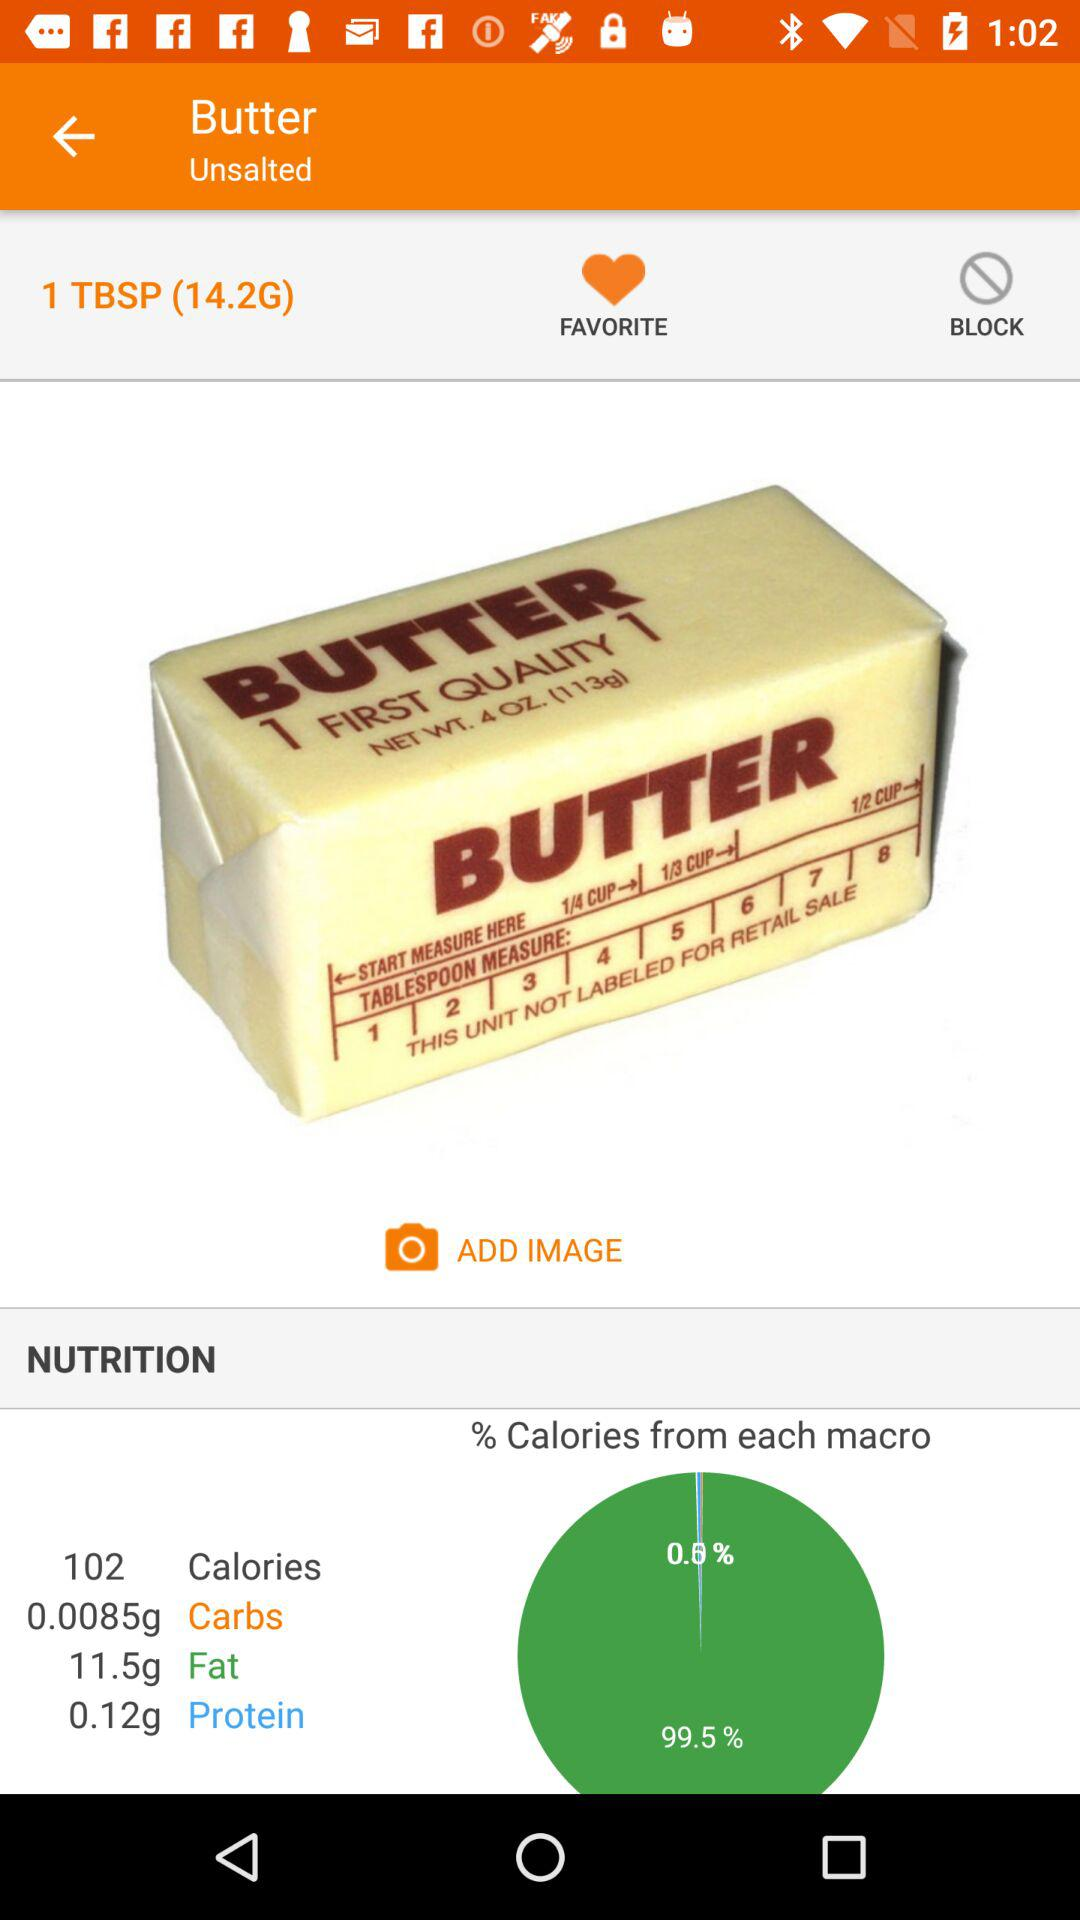How many calories are there in butter? There are 102 calories in butter. 